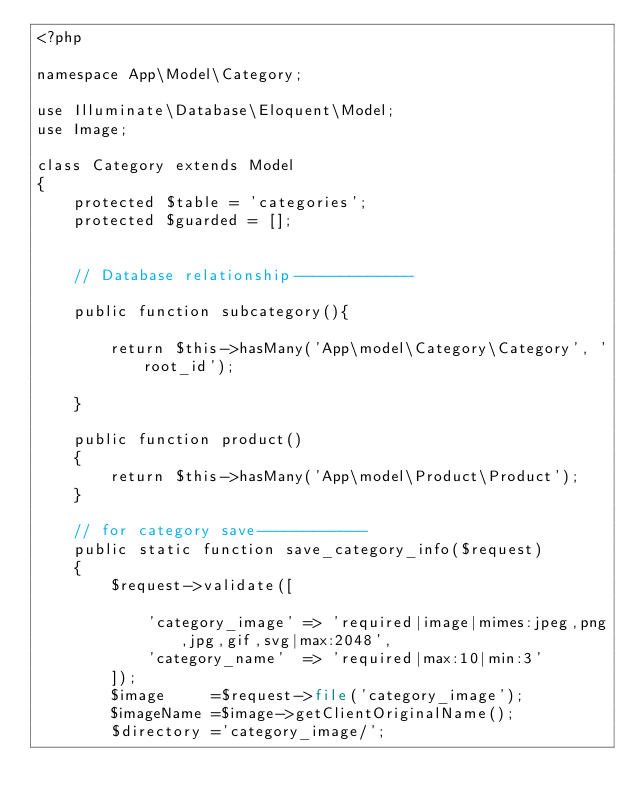Convert code to text. <code><loc_0><loc_0><loc_500><loc_500><_PHP_><?php

namespace App\Model\Category;

use Illuminate\Database\Eloquent\Model;
use Image;

class Category extends Model
{
    protected $table = 'categories';
    protected $guarded = [];


    // Database relationship-------------

    public function subcategory(){

        return $this->hasMany('App\model\Category\Category', 'root_id');

    }

    public function product()
    {
        return $this->hasMany('App\model\Product\Product');
    }

    // for category save------------
    public static function save_category_info($request)
    {
        $request->validate([

            'category_image' => 'required|image|mimes:jpeg,png,jpg,gif,svg|max:2048',
            'category_name'  => 'required|max:10|min:3'
        ]);
        $image     =$request->file('category_image');
        $imageName =$image->getClientOriginalName();
        $directory ='category_image/';</code> 